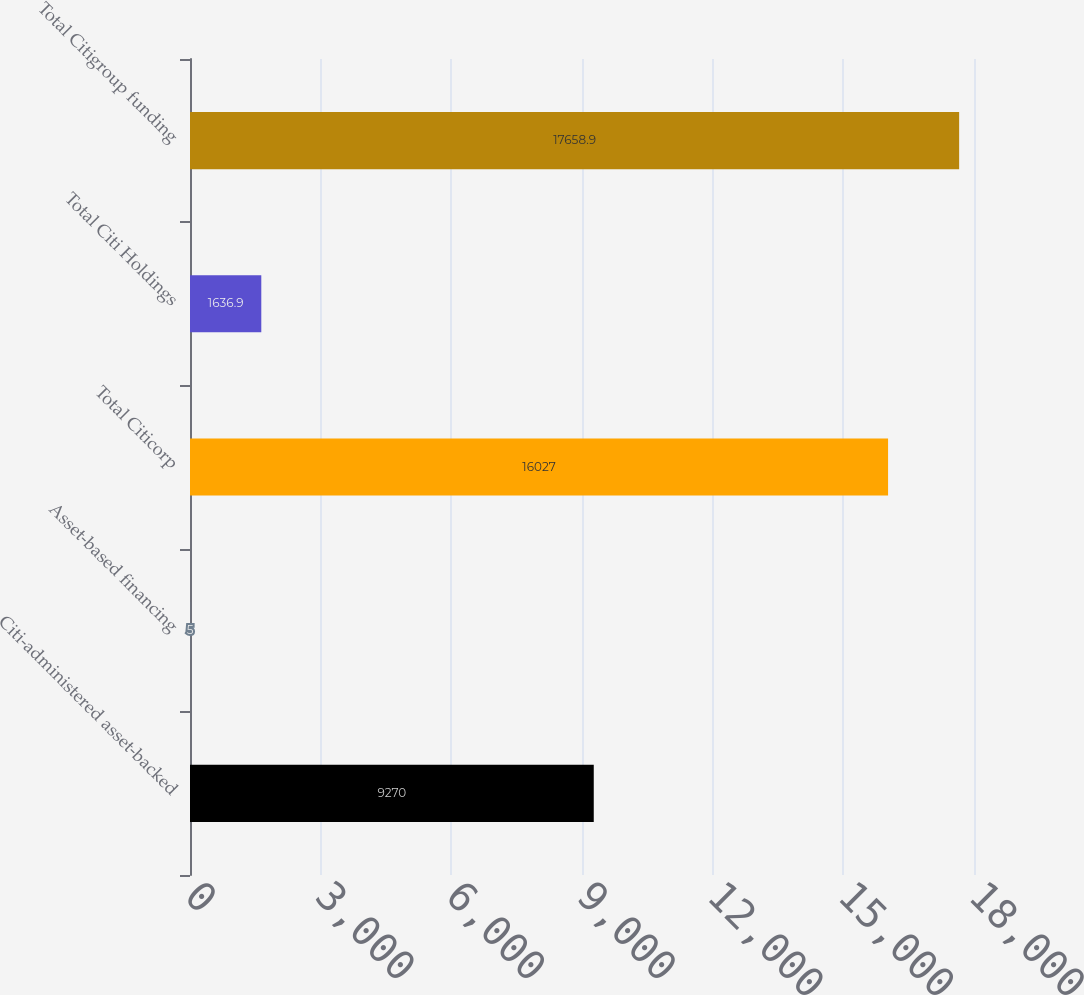Convert chart to OTSL. <chart><loc_0><loc_0><loc_500><loc_500><bar_chart><fcel>Citi-administered asset-backed<fcel>Asset-based financing<fcel>Total Citicorp<fcel>Total Citi Holdings<fcel>Total Citigroup funding<nl><fcel>9270<fcel>5<fcel>16027<fcel>1636.9<fcel>17658.9<nl></chart> 